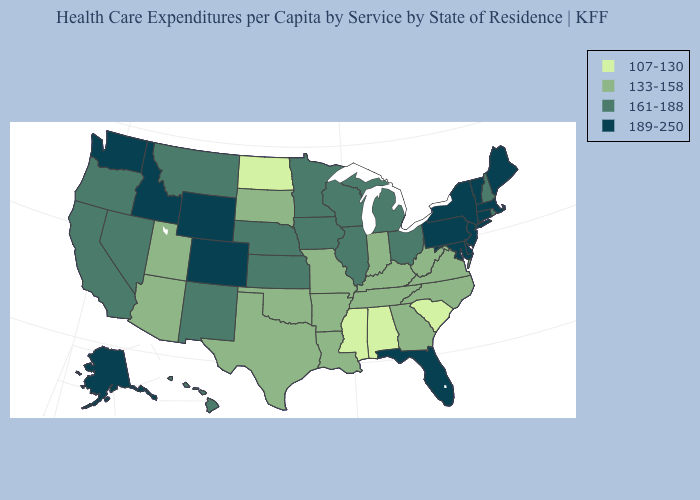Among the states that border New York , which have the highest value?
Keep it brief. Connecticut, Massachusetts, New Jersey, Pennsylvania, Vermont. Among the states that border Nebraska , does Colorado have the highest value?
Keep it brief. Yes. What is the highest value in the USA?
Concise answer only. 189-250. What is the lowest value in the Northeast?
Keep it brief. 161-188. What is the value of North Carolina?
Be succinct. 133-158. Is the legend a continuous bar?
Quick response, please. No. Does Oklahoma have the same value as North Dakota?
Quick response, please. No. Does Georgia have the highest value in the USA?
Keep it brief. No. Is the legend a continuous bar?
Answer briefly. No. Name the states that have a value in the range 133-158?
Quick response, please. Arizona, Arkansas, Georgia, Indiana, Kentucky, Louisiana, Missouri, North Carolina, Oklahoma, South Dakota, Tennessee, Texas, Utah, Virginia, West Virginia. Is the legend a continuous bar?
Write a very short answer. No. Name the states that have a value in the range 107-130?
Short answer required. Alabama, Mississippi, North Dakota, South Carolina. Name the states that have a value in the range 107-130?
Quick response, please. Alabama, Mississippi, North Dakota, South Carolina. What is the value of Missouri?
Write a very short answer. 133-158. Name the states that have a value in the range 133-158?
Keep it brief. Arizona, Arkansas, Georgia, Indiana, Kentucky, Louisiana, Missouri, North Carolina, Oklahoma, South Dakota, Tennessee, Texas, Utah, Virginia, West Virginia. 